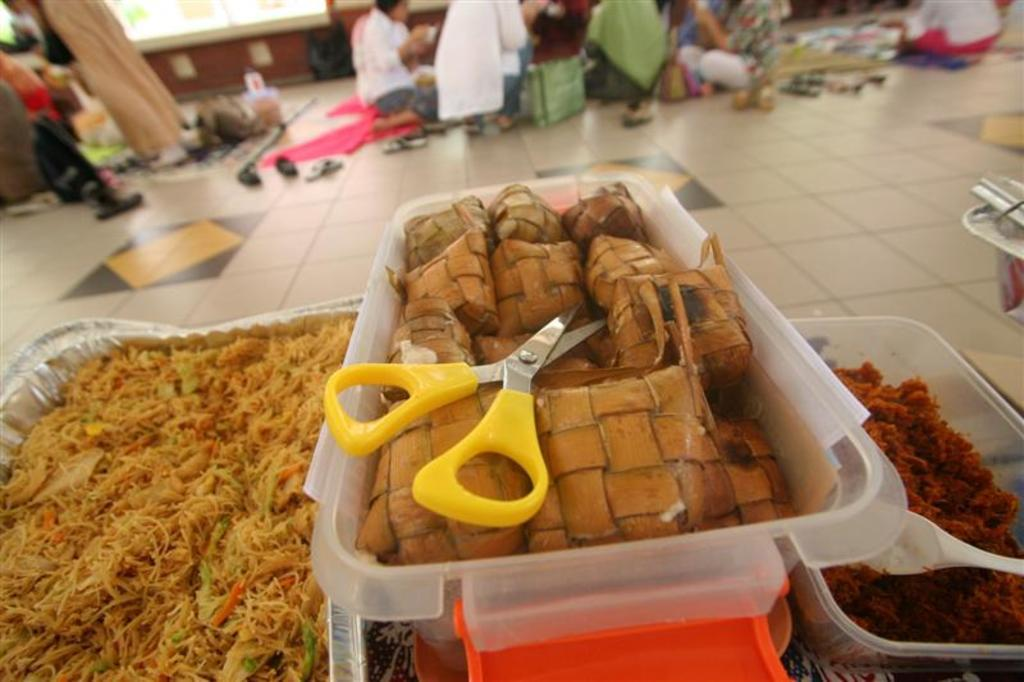What type of food items are in the boxes in the image? The specific type of food items in the boxes is not mentioned, but there are food items in boxes in the image. What tool is visible in the image? Scissors are visible in the image. What utensil can be seen in the image? There is a spoon in the image. What can be seen in the background of the image? There are people and objects on the floor in the background of the image. What type of market can be seen in the image? There is no market present in the image; it features food items in boxes, scissors, a spoon, people, and objects on the floor in the background. Is there a stream visible in the image? There is no stream present in the image. 